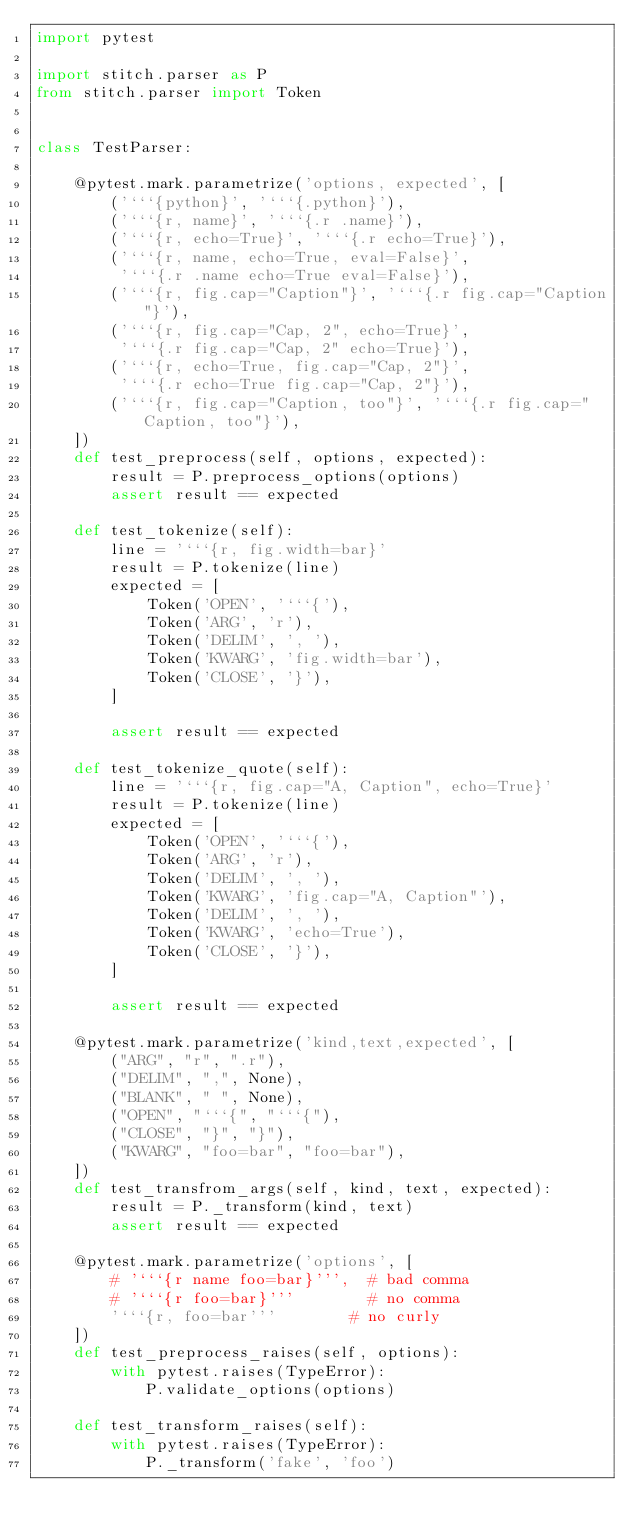Convert code to text. <code><loc_0><loc_0><loc_500><loc_500><_Python_>import pytest

import stitch.parser as P
from stitch.parser import Token


class TestParser:

    @pytest.mark.parametrize('options, expected', [
        ('```{python}', '```{.python}'),
        ('```{r, name}', '```{.r .name}'),
        ('```{r, echo=True}', '```{.r echo=True}'),
        ('```{r, name, echo=True, eval=False}',
         '```{.r .name echo=True eval=False}'),
        ('```{r, fig.cap="Caption"}', '```{.r fig.cap="Caption"}'),
        ('```{r, fig.cap="Cap, 2", echo=True}',
         '```{.r fig.cap="Cap, 2" echo=True}'),
        ('```{r, echo=True, fig.cap="Cap, 2"}',
         '```{.r echo=True fig.cap="Cap, 2"}'),
        ('```{r, fig.cap="Caption, too"}', '```{.r fig.cap="Caption, too"}'),
    ])
    def test_preprocess(self, options, expected):
        result = P.preprocess_options(options)
        assert result == expected

    def test_tokenize(self):
        line = '```{r, fig.width=bar}'
        result = P.tokenize(line)
        expected = [
            Token('OPEN', '```{'),
            Token('ARG', 'r'),
            Token('DELIM', ', '),
            Token('KWARG', 'fig.width=bar'),
            Token('CLOSE', '}'),
        ]

        assert result == expected

    def test_tokenize_quote(self):
        line = '```{r, fig.cap="A, Caption", echo=True}'
        result = P.tokenize(line)
        expected = [
            Token('OPEN', '```{'),
            Token('ARG', 'r'),
            Token('DELIM', ', '),
            Token('KWARG', 'fig.cap="A, Caption"'),
            Token('DELIM', ', '),
            Token('KWARG', 'echo=True'),
            Token('CLOSE', '}'),
        ]

        assert result == expected

    @pytest.mark.parametrize('kind,text,expected', [
        ("ARG", "r", ".r"),
        ("DELIM", ",", None),
        ("BLANK", " ", None),
        ("OPEN", "```{", "```{"),
        ("CLOSE", "}", "}"),
        ("KWARG", "foo=bar", "foo=bar"),
    ])
    def test_transfrom_args(self, kind, text, expected):
        result = P._transform(kind, text)
        assert result == expected

    @pytest.mark.parametrize('options', [
        # '```{r name foo=bar}''',  # bad comma
        # '```{r foo=bar}'''        # no comma
        '```{r, foo=bar'''        # no curly
    ])
    def test_preprocess_raises(self, options):
        with pytest.raises(TypeError):
            P.validate_options(options)

    def test_transform_raises(self):
        with pytest.raises(TypeError):
            P._transform('fake', 'foo')
</code> 